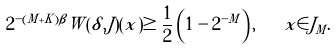Convert formula to latex. <formula><loc_0><loc_0><loc_500><loc_500>2 ^ { - ( M + K ) \beta } W ( \delta , J ) ( x ) \geq \frac { 1 } { 2 } \left ( 1 - 2 ^ { - M } \right ) , \quad x \in J _ { M } .</formula> 